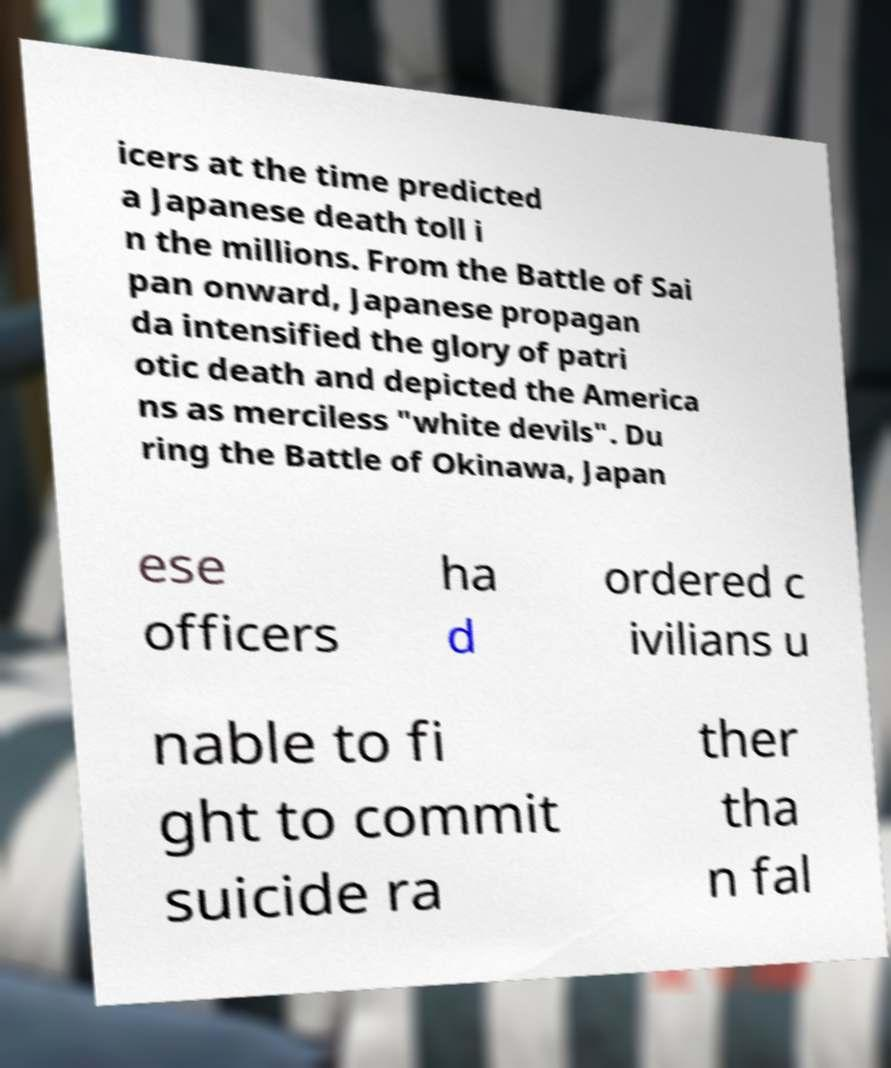There's text embedded in this image that I need extracted. Can you transcribe it verbatim? icers at the time predicted a Japanese death toll i n the millions. From the Battle of Sai pan onward, Japanese propagan da intensified the glory of patri otic death and depicted the America ns as merciless "white devils". Du ring the Battle of Okinawa, Japan ese officers ha d ordered c ivilians u nable to fi ght to commit suicide ra ther tha n fal 